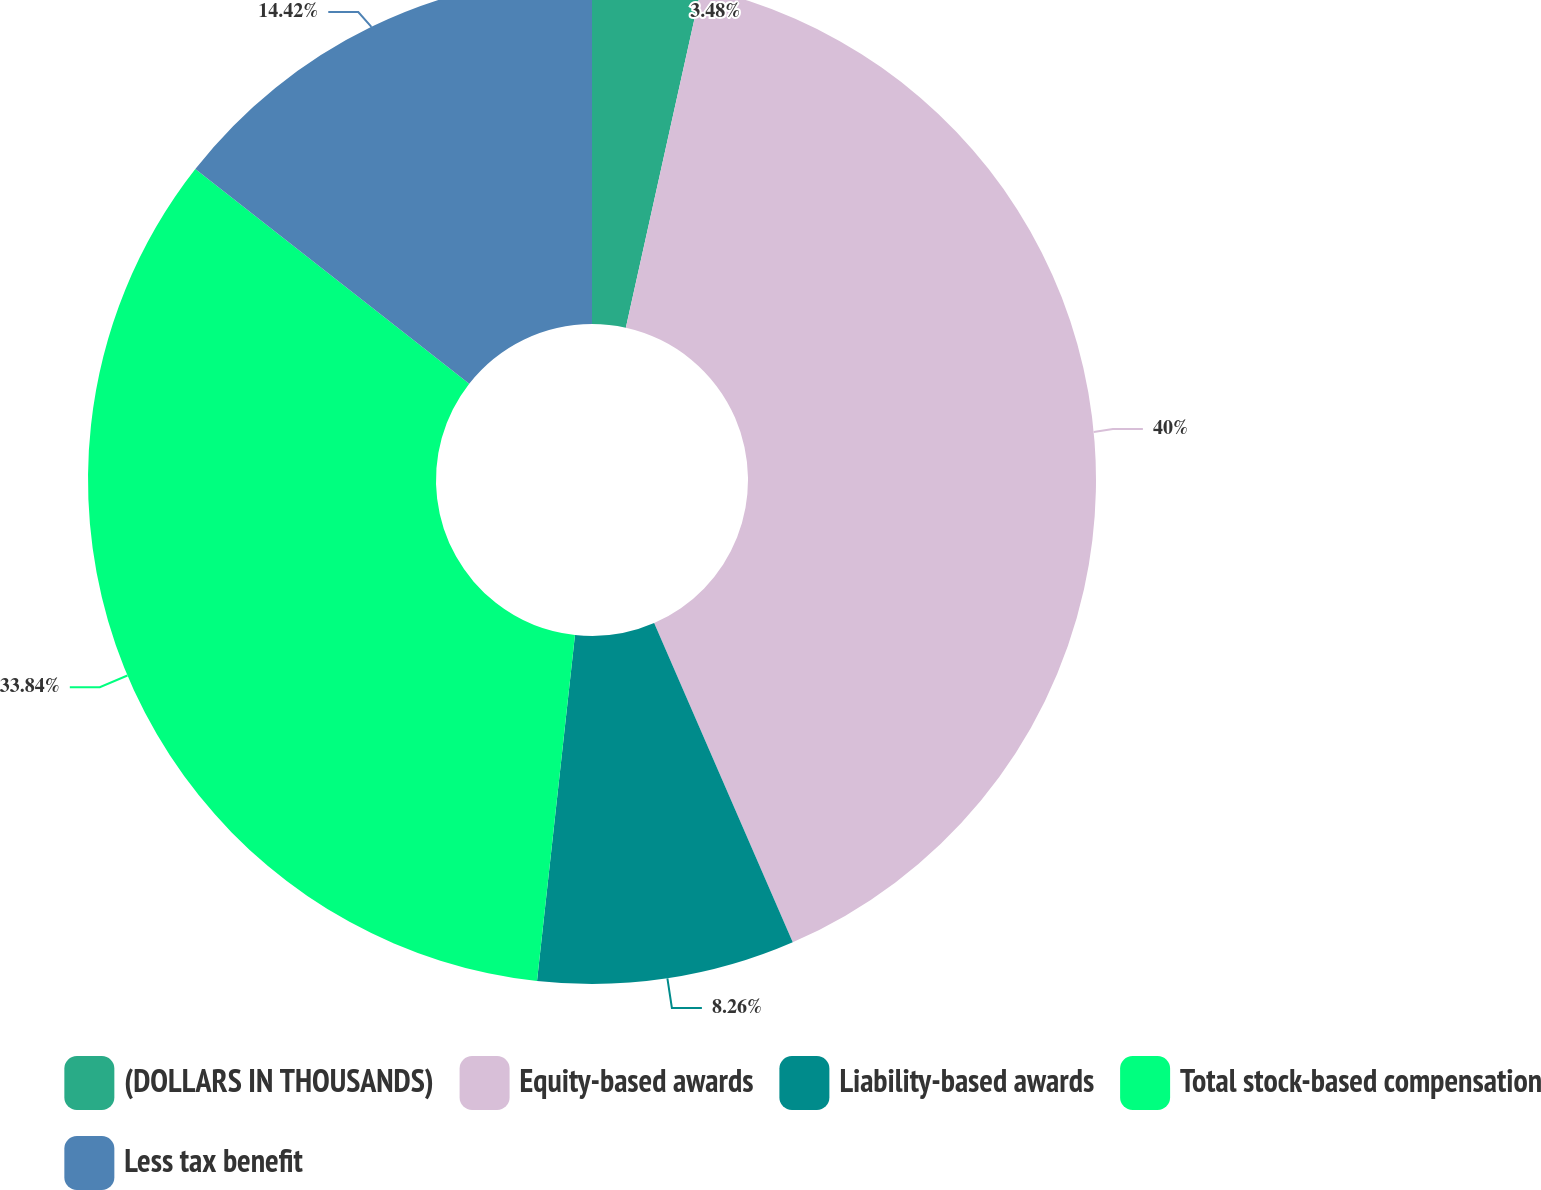<chart> <loc_0><loc_0><loc_500><loc_500><pie_chart><fcel>(DOLLARS IN THOUSANDS)<fcel>Equity-based awards<fcel>Liability-based awards<fcel>Total stock-based compensation<fcel>Less tax benefit<nl><fcel>3.48%<fcel>40.0%<fcel>8.26%<fcel>33.84%<fcel>14.42%<nl></chart> 